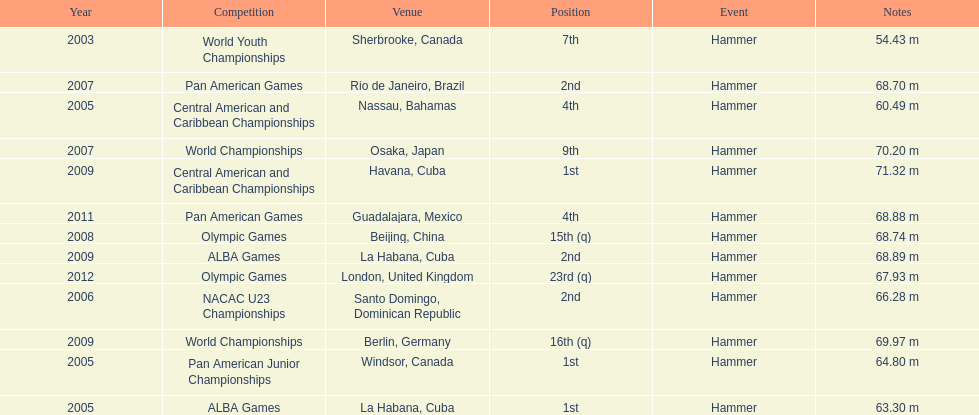Does arasay thondike have more/less than 4 1st place tournament finishes? Less. 